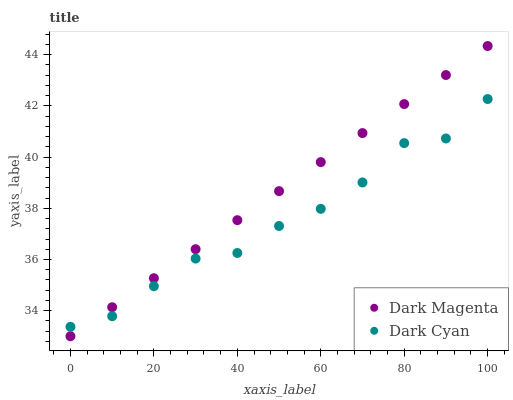Does Dark Cyan have the minimum area under the curve?
Answer yes or no. Yes. Does Dark Magenta have the maximum area under the curve?
Answer yes or no. Yes. Does Dark Magenta have the minimum area under the curve?
Answer yes or no. No. Is Dark Magenta the smoothest?
Answer yes or no. Yes. Is Dark Cyan the roughest?
Answer yes or no. Yes. Is Dark Magenta the roughest?
Answer yes or no. No. Does Dark Magenta have the lowest value?
Answer yes or no. Yes. Does Dark Magenta have the highest value?
Answer yes or no. Yes. Does Dark Magenta intersect Dark Cyan?
Answer yes or no. Yes. Is Dark Magenta less than Dark Cyan?
Answer yes or no. No. Is Dark Magenta greater than Dark Cyan?
Answer yes or no. No. 